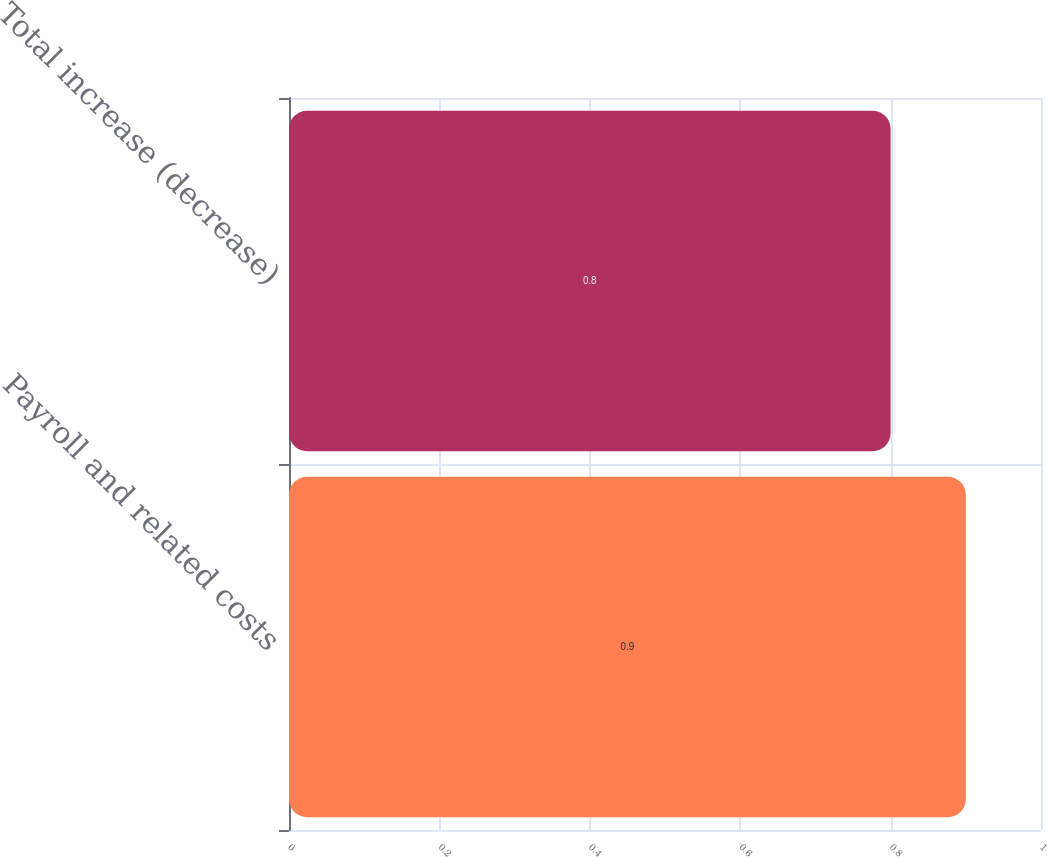Convert chart. <chart><loc_0><loc_0><loc_500><loc_500><bar_chart><fcel>Payroll and related costs<fcel>Total increase (decrease)<nl><fcel>0.9<fcel>0.8<nl></chart> 